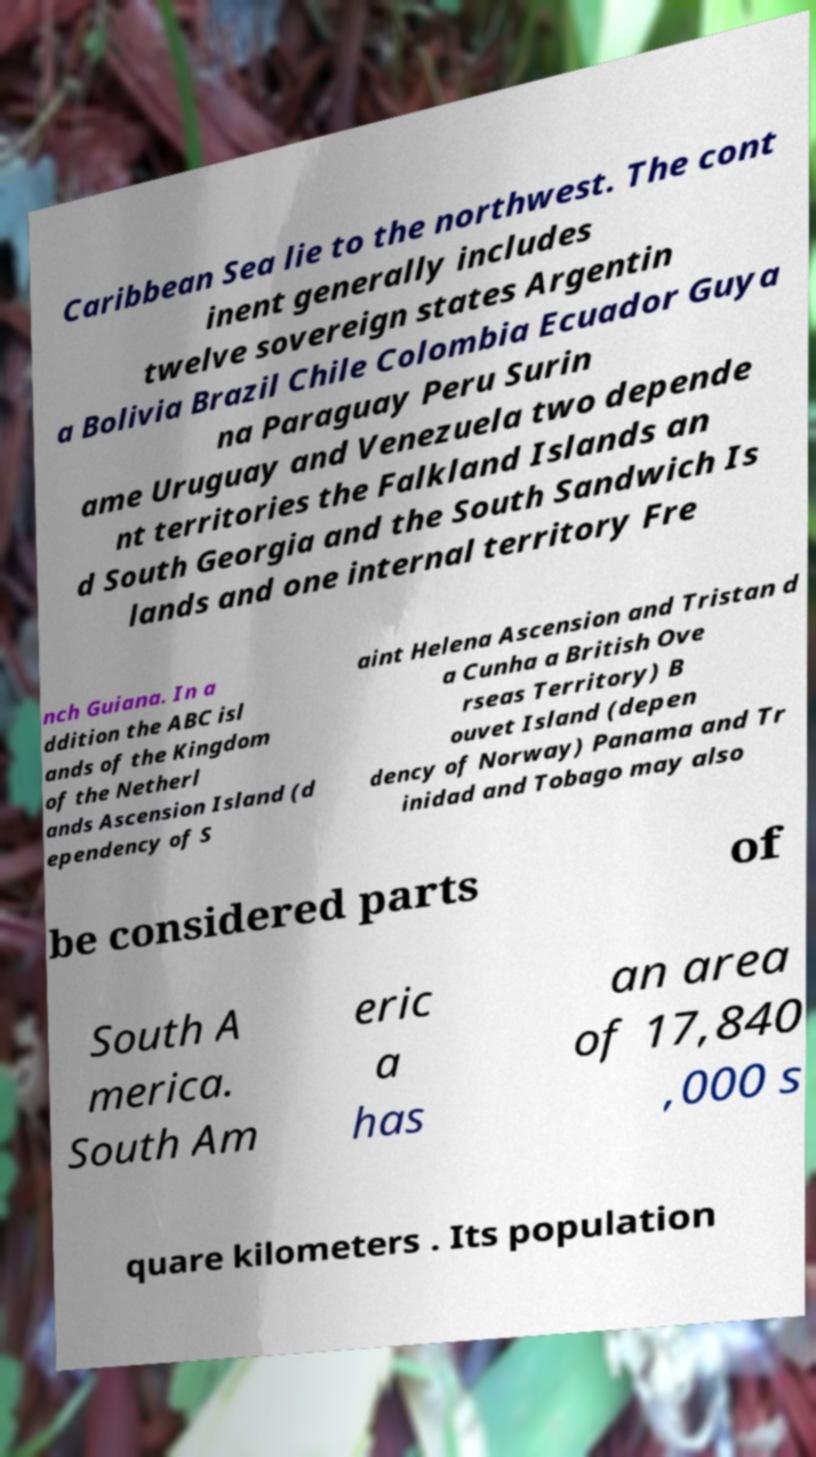There's text embedded in this image that I need extracted. Can you transcribe it verbatim? Caribbean Sea lie to the northwest. The cont inent generally includes twelve sovereign states Argentin a Bolivia Brazil Chile Colombia Ecuador Guya na Paraguay Peru Surin ame Uruguay and Venezuela two depende nt territories the Falkland Islands an d South Georgia and the South Sandwich Is lands and one internal territory Fre nch Guiana. In a ddition the ABC isl ands of the Kingdom of the Netherl ands Ascension Island (d ependency of S aint Helena Ascension and Tristan d a Cunha a British Ove rseas Territory) B ouvet Island (depen dency of Norway) Panama and Tr inidad and Tobago may also be considered parts of South A merica. South Am eric a has an area of 17,840 ,000 s quare kilometers . Its population 